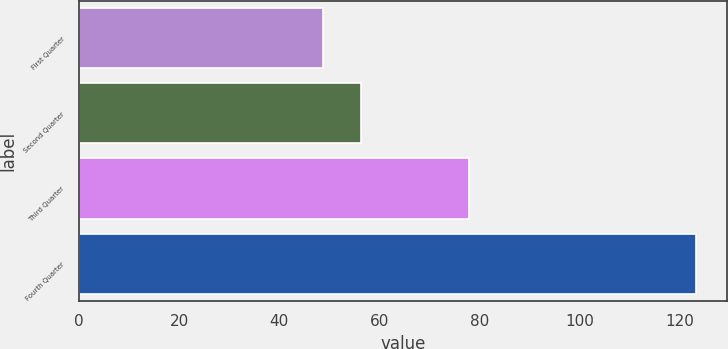<chart> <loc_0><loc_0><loc_500><loc_500><bar_chart><fcel>First Quarter<fcel>Second Quarter<fcel>Third Quarter<fcel>Fourth Quarter<nl><fcel>48.81<fcel>56.25<fcel>77.87<fcel>123.19<nl></chart> 